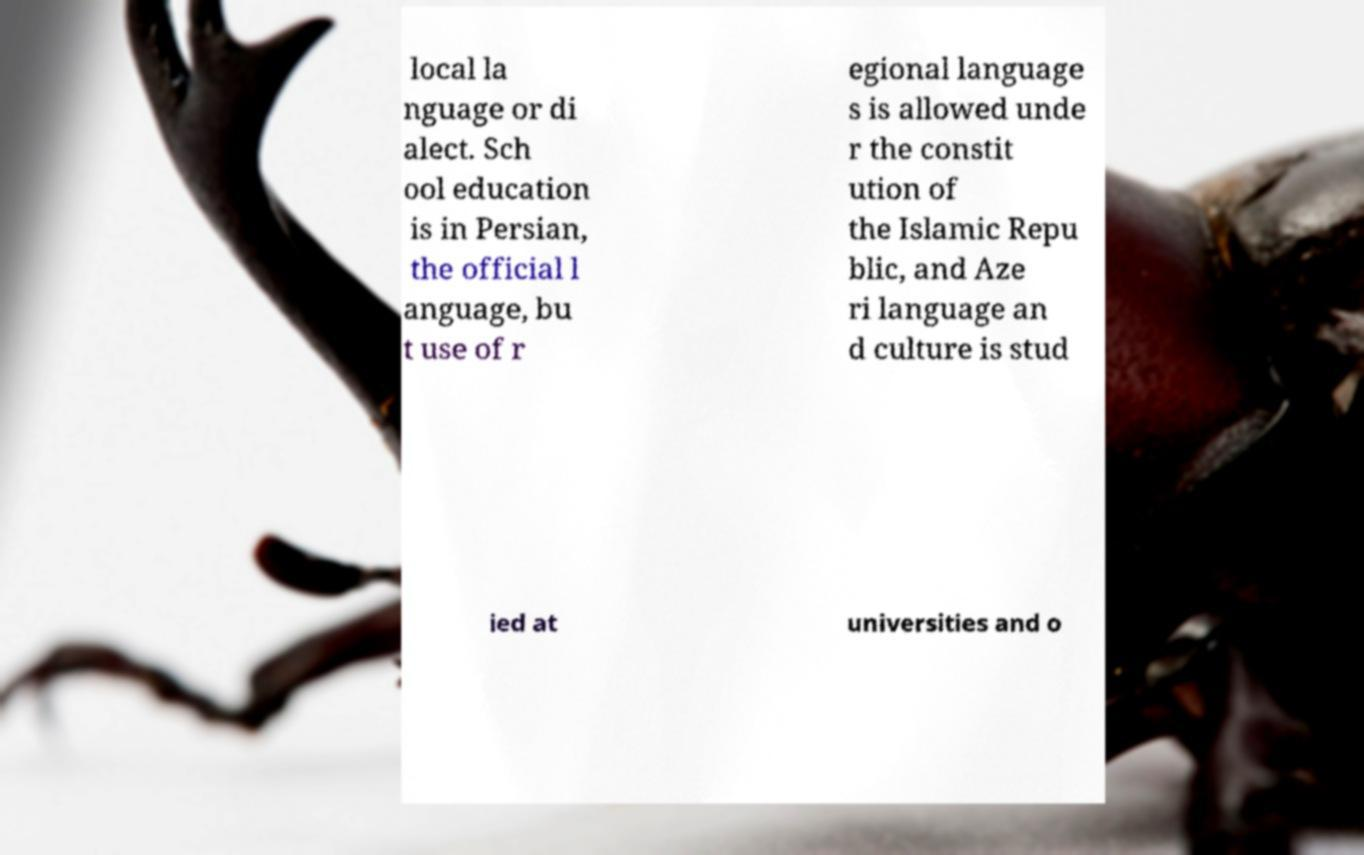What messages or text are displayed in this image? I need them in a readable, typed format. local la nguage or di alect. Sch ool education is in Persian, the official l anguage, bu t use of r egional language s is allowed unde r the constit ution of the Islamic Repu blic, and Aze ri language an d culture is stud ied at universities and o 